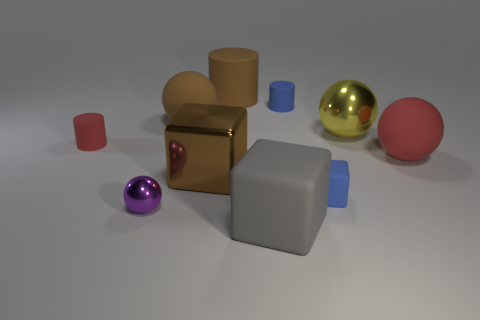Subtract all tiny blue cylinders. How many cylinders are left? 2 Subtract 2 spheres. How many spheres are left? 2 Subtract all brown balls. How many balls are left? 3 Subtract all green spheres. Subtract all blue cylinders. How many spheres are left? 4 Subtract all balls. How many objects are left? 6 Subtract all tiny cyan rubber cylinders. Subtract all tiny shiny objects. How many objects are left? 9 Add 8 big gray objects. How many big gray objects are left? 9 Add 3 brown spheres. How many brown spheres exist? 4 Subtract 0 cyan balls. How many objects are left? 10 